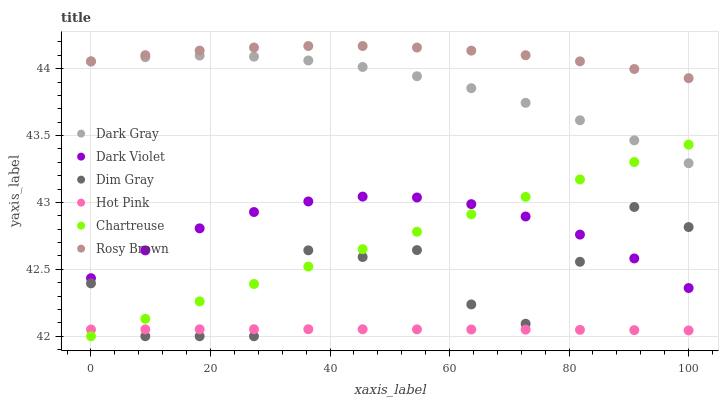Does Hot Pink have the minimum area under the curve?
Answer yes or no. Yes. Does Rosy Brown have the maximum area under the curve?
Answer yes or no. Yes. Does Dark Violet have the minimum area under the curve?
Answer yes or no. No. Does Dark Violet have the maximum area under the curve?
Answer yes or no. No. Is Chartreuse the smoothest?
Answer yes or no. Yes. Is Dim Gray the roughest?
Answer yes or no. Yes. Is Rosy Brown the smoothest?
Answer yes or no. No. Is Rosy Brown the roughest?
Answer yes or no. No. Does Dim Gray have the lowest value?
Answer yes or no. Yes. Does Dark Violet have the lowest value?
Answer yes or no. No. Does Rosy Brown have the highest value?
Answer yes or no. Yes. Does Dark Violet have the highest value?
Answer yes or no. No. Is Dark Violet less than Rosy Brown?
Answer yes or no. Yes. Is Dark Violet greater than Hot Pink?
Answer yes or no. Yes. Does Chartreuse intersect Dim Gray?
Answer yes or no. Yes. Is Chartreuse less than Dim Gray?
Answer yes or no. No. Is Chartreuse greater than Dim Gray?
Answer yes or no. No. Does Dark Violet intersect Rosy Brown?
Answer yes or no. No. 